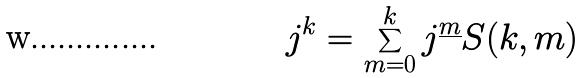Convert formula to latex. <formula><loc_0><loc_0><loc_500><loc_500>j ^ { k } = \sum _ { m = 0 } ^ { k } j ^ { \underline { m } } S ( k , m )</formula> 